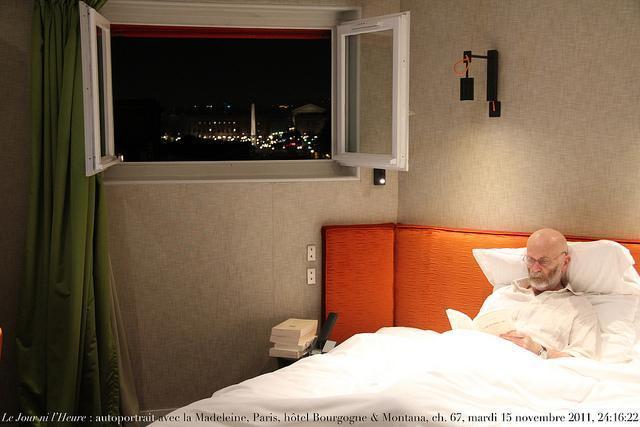How many pillows are there?
Give a very brief answer. 2. How many people are there?
Give a very brief answer. 1. 